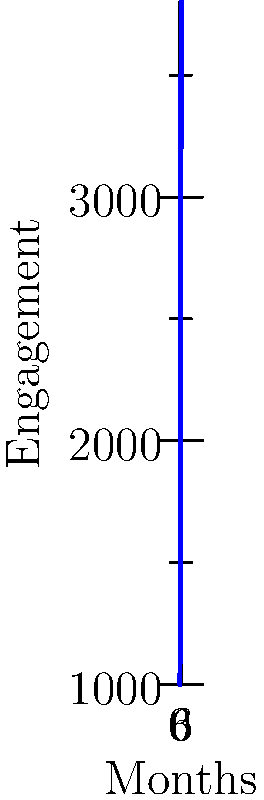As a social media manager, you're analyzing the engagement trends for a client's account. Based on the line graph showing monthly engagement from January to July, which month showed the most significant increase in engagement compared to the previous month? To determine the month with the most significant increase in engagement compared to the previous month, we need to calculate the difference in engagement between each consecutive pair of months:

1. January to February: 1500 - 1000 = 500
2. February to March: 2200 - 1500 = 700
3. March to April: 3000 - 2200 = 800
4. April to May: 3500 - 3000 = 500
5. May to June: 3200 - 3500 = -300 (decrease)
6. June to July: 3800 - 3200 = 600

The largest increase is 800, which occurred between March and April.
Answer: April 